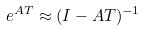Convert formula to latex. <formula><loc_0><loc_0><loc_500><loc_500>e ^ { A T } \approx ( I - A T ) ^ { - 1 }</formula> 